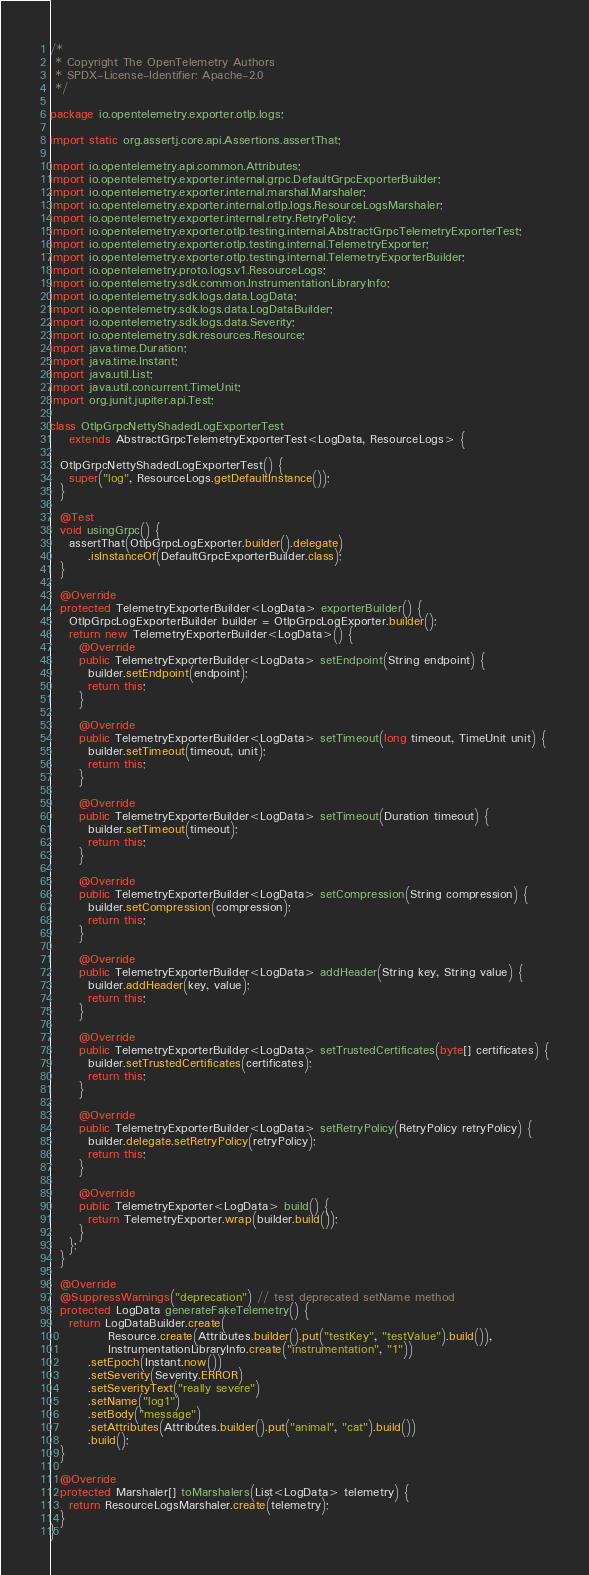Convert code to text. <code><loc_0><loc_0><loc_500><loc_500><_Java_>/*
 * Copyright The OpenTelemetry Authors
 * SPDX-License-Identifier: Apache-2.0
 */

package io.opentelemetry.exporter.otlp.logs;

import static org.assertj.core.api.Assertions.assertThat;

import io.opentelemetry.api.common.Attributes;
import io.opentelemetry.exporter.internal.grpc.DefaultGrpcExporterBuilder;
import io.opentelemetry.exporter.internal.marshal.Marshaler;
import io.opentelemetry.exporter.internal.otlp.logs.ResourceLogsMarshaler;
import io.opentelemetry.exporter.internal.retry.RetryPolicy;
import io.opentelemetry.exporter.otlp.testing.internal.AbstractGrpcTelemetryExporterTest;
import io.opentelemetry.exporter.otlp.testing.internal.TelemetryExporter;
import io.opentelemetry.exporter.otlp.testing.internal.TelemetryExporterBuilder;
import io.opentelemetry.proto.logs.v1.ResourceLogs;
import io.opentelemetry.sdk.common.InstrumentationLibraryInfo;
import io.opentelemetry.sdk.logs.data.LogData;
import io.opentelemetry.sdk.logs.data.LogDataBuilder;
import io.opentelemetry.sdk.logs.data.Severity;
import io.opentelemetry.sdk.resources.Resource;
import java.time.Duration;
import java.time.Instant;
import java.util.List;
import java.util.concurrent.TimeUnit;
import org.junit.jupiter.api.Test;

class OtlpGrpcNettyShadedLogExporterTest
    extends AbstractGrpcTelemetryExporterTest<LogData, ResourceLogs> {

  OtlpGrpcNettyShadedLogExporterTest() {
    super("log", ResourceLogs.getDefaultInstance());
  }

  @Test
  void usingGrpc() {
    assertThat(OtlpGrpcLogExporter.builder().delegate)
        .isInstanceOf(DefaultGrpcExporterBuilder.class);
  }

  @Override
  protected TelemetryExporterBuilder<LogData> exporterBuilder() {
    OtlpGrpcLogExporterBuilder builder = OtlpGrpcLogExporter.builder();
    return new TelemetryExporterBuilder<LogData>() {
      @Override
      public TelemetryExporterBuilder<LogData> setEndpoint(String endpoint) {
        builder.setEndpoint(endpoint);
        return this;
      }

      @Override
      public TelemetryExporterBuilder<LogData> setTimeout(long timeout, TimeUnit unit) {
        builder.setTimeout(timeout, unit);
        return this;
      }

      @Override
      public TelemetryExporterBuilder<LogData> setTimeout(Duration timeout) {
        builder.setTimeout(timeout);
        return this;
      }

      @Override
      public TelemetryExporterBuilder<LogData> setCompression(String compression) {
        builder.setCompression(compression);
        return this;
      }

      @Override
      public TelemetryExporterBuilder<LogData> addHeader(String key, String value) {
        builder.addHeader(key, value);
        return this;
      }

      @Override
      public TelemetryExporterBuilder<LogData> setTrustedCertificates(byte[] certificates) {
        builder.setTrustedCertificates(certificates);
        return this;
      }

      @Override
      public TelemetryExporterBuilder<LogData> setRetryPolicy(RetryPolicy retryPolicy) {
        builder.delegate.setRetryPolicy(retryPolicy);
        return this;
      }

      @Override
      public TelemetryExporter<LogData> build() {
        return TelemetryExporter.wrap(builder.build());
      }
    };
  }

  @Override
  @SuppressWarnings("deprecation") // test deprecated setName method
  protected LogData generateFakeTelemetry() {
    return LogDataBuilder.create(
            Resource.create(Attributes.builder().put("testKey", "testValue").build()),
            InstrumentationLibraryInfo.create("instrumentation", "1"))
        .setEpoch(Instant.now())
        .setSeverity(Severity.ERROR)
        .setSeverityText("really severe")
        .setName("log1")
        .setBody("message")
        .setAttributes(Attributes.builder().put("animal", "cat").build())
        .build();
  }

  @Override
  protected Marshaler[] toMarshalers(List<LogData> telemetry) {
    return ResourceLogsMarshaler.create(telemetry);
  }
}
</code> 